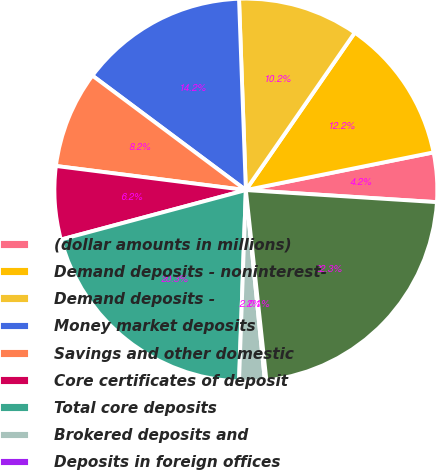<chart> <loc_0><loc_0><loc_500><loc_500><pie_chart><fcel>(dollar amounts in millions)<fcel>Demand deposits - noninterest-<fcel>Demand deposits -<fcel>Money market deposits<fcel>Savings and other domestic<fcel>Core certificates of deposit<fcel>Total core deposits<fcel>Brokered deposits and<fcel>Deposits in foreign offices<fcel>Total deposits<nl><fcel>4.16%<fcel>12.21%<fcel>10.2%<fcel>14.23%<fcel>8.19%<fcel>6.17%<fcel>20.27%<fcel>2.15%<fcel>0.13%<fcel>22.28%<nl></chart> 